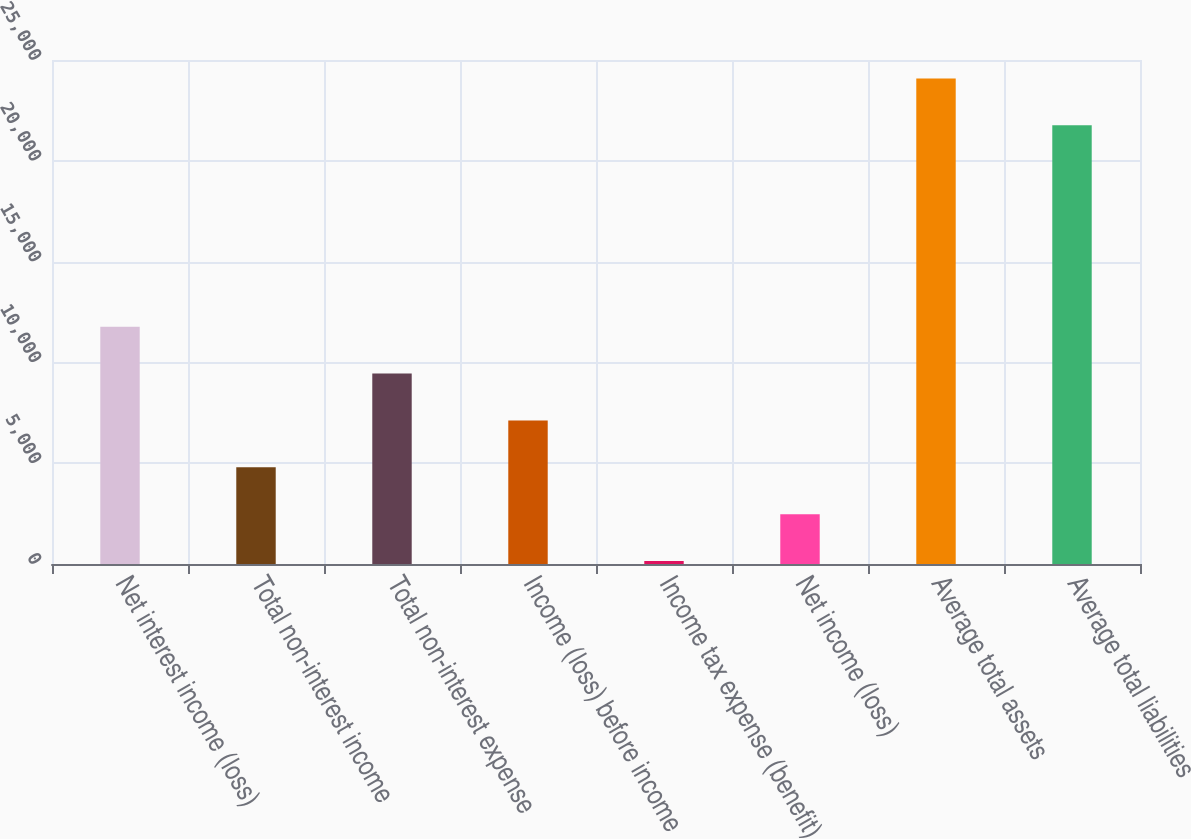<chart> <loc_0><loc_0><loc_500><loc_500><bar_chart><fcel>Net interest income (loss)<fcel>Total non-interest income<fcel>Total non-interest expense<fcel>Income (loss) before income<fcel>Income tax expense (benefit)<fcel>Net income (loss)<fcel>Average total assets<fcel>Average total liabilities<nl><fcel>11772.1<fcel>4795.98<fcel>9446.76<fcel>7121.37<fcel>145.2<fcel>2470.59<fcel>24086.5<fcel>21761.1<nl></chart> 